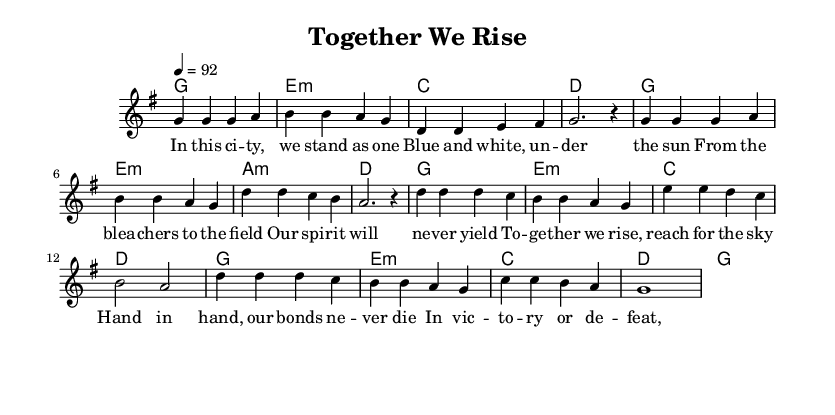What is the key signature of this music? The key signature is G major, indicated by the presence of one sharp (F#).
Answer: G major What is the time signature of this music? The time signature is 4/4, which shows that there are four beats per measure.
Answer: 4/4 What is the tempo marking for this piece? The tempo marking is indicated as 92 beats per minute, which corresponds to a moderate pace.
Answer: 92 How many measures are there in the verse section? The verse section consists of eight measures, as determined by counting the sections in the melody that are enclosed between the bar lines.
Answer: Eight What is the primary theme of the chorus lyrics? The primary theme revolves around unity and togetherness, emphasizing the idea of rising together as a community.
Answer: Unity In the chorus, what is represented by "Dodger pride"? "Dodger pride" signifies the shared identity and spirit of the Dodgers fans, highlighting loyalty and community.
Answer: Loyalty What is the harmonic progression in the verse? The harmonic progression in the verse is G major, E minor, C major, D major, which creates a standard structure often found in R&B music.
Answer: G E minor C D 